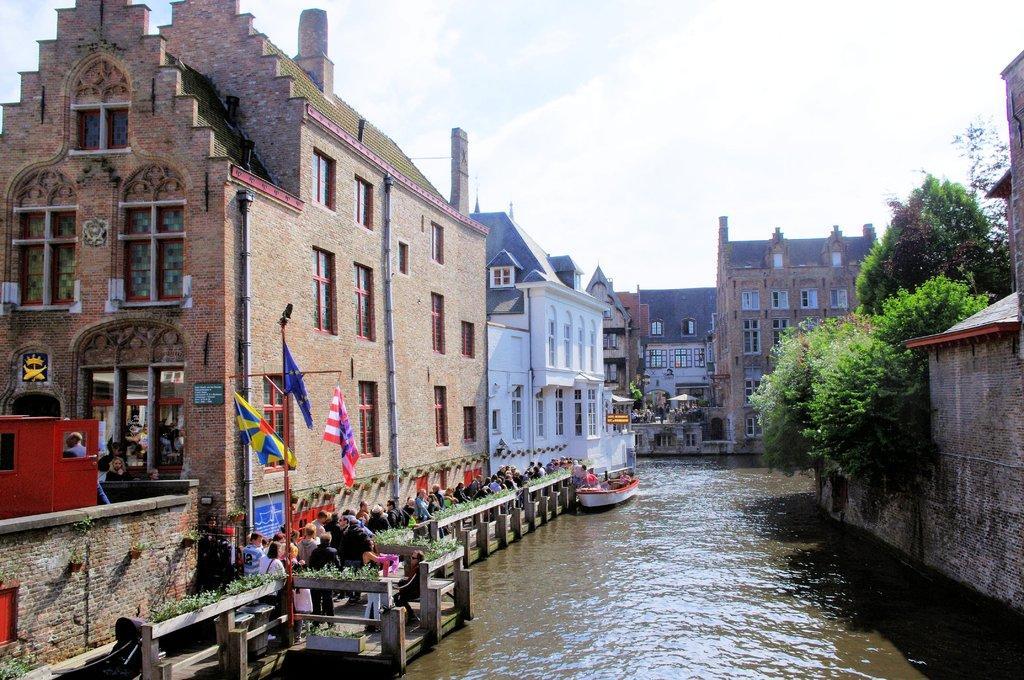In one or two sentences, can you explain what this image depicts? This is the picture of a city. In this image there are group of people standing behind the wooden railing and there are flags. There are buildings and trees and there is a boat on the water. At the top there is sky and there are clouds. At the bottom there is water. 